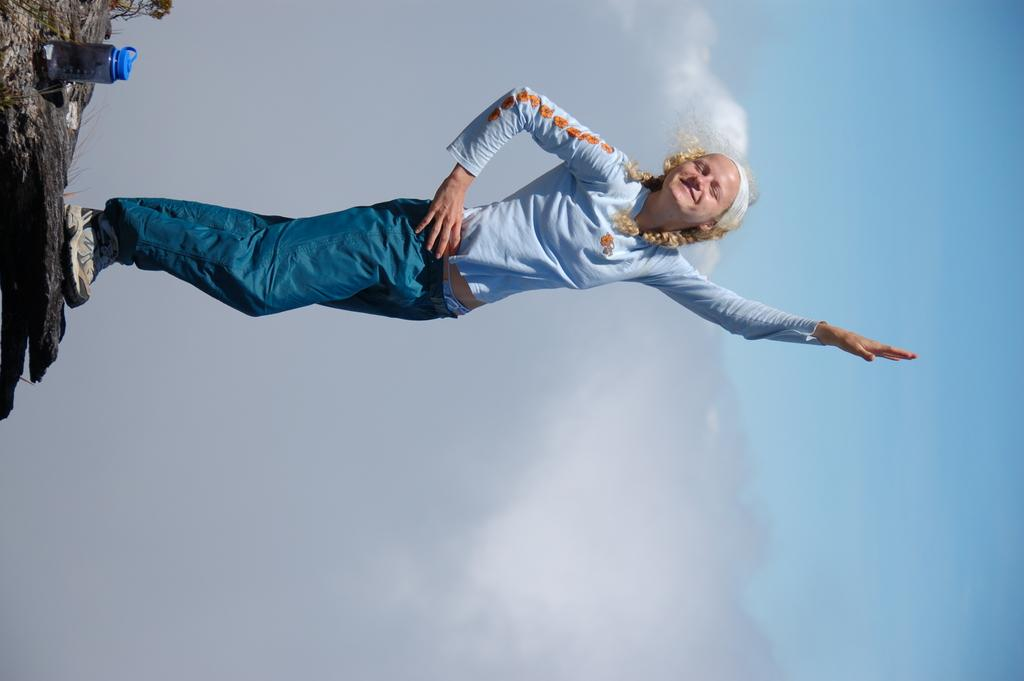Who is present in the image? There is a woman in the image. What is the woman wearing? The woman is wearing a blue dress. Where is the woman standing? The woman is standing on a rock. What object is beside the woman? There is a bottle beside the woman. What can be seen in the background of the image? The sky is visible in the background of the image, and clouds are present in the sky. What type of collar can be seen on the page in the image? There is no page or collar present in the image. 